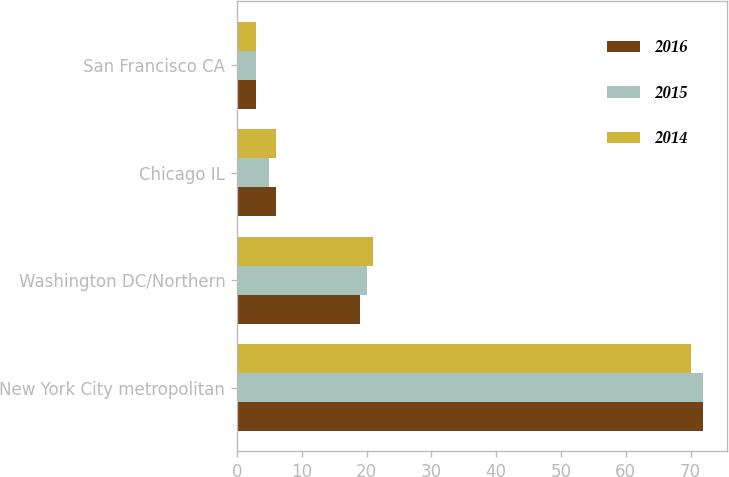<chart> <loc_0><loc_0><loc_500><loc_500><stacked_bar_chart><ecel><fcel>New York City metropolitan<fcel>Washington DC/Northern<fcel>Chicago IL<fcel>San Francisco CA<nl><fcel>2016<fcel>72<fcel>19<fcel>6<fcel>3<nl><fcel>2015<fcel>72<fcel>20<fcel>5<fcel>3<nl><fcel>2014<fcel>70<fcel>21<fcel>6<fcel>3<nl></chart> 